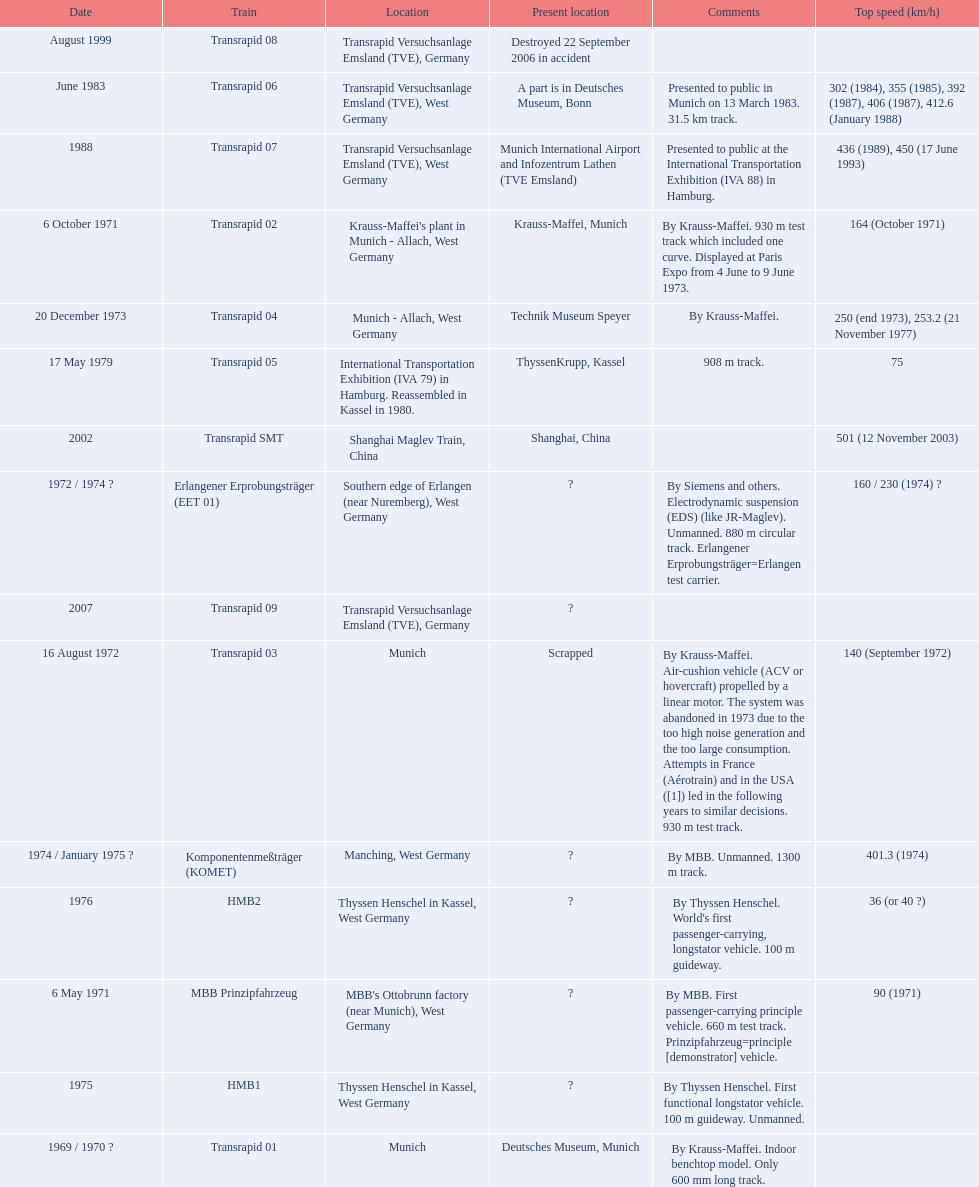What is the top speed reached by any trains shown here? 501 (12 November 2003). What train has reached a top speed of 501? Transrapid SMT. 